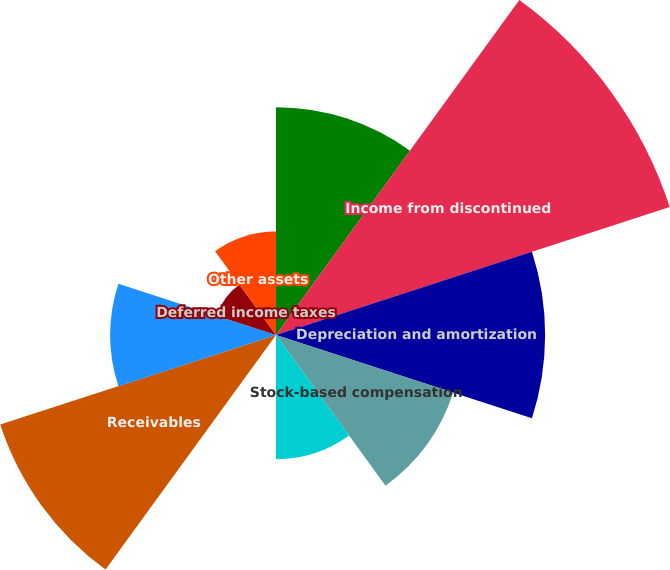Convert chart. <chart><loc_0><loc_0><loc_500><loc_500><pie_chart><fcel>Net income<fcel>Income from discontinued<fcel>Depreciation and amortization<fcel>Stock-based compensation<fcel>Net gain on sales and<fcel>Other<fcel>Receivables<fcel>Inventory prepaid expenses and<fcel>Deferred income taxes<fcel>Other assets<nl><fcel>12.36%<fcel>22.46%<fcel>14.6%<fcel>10.11%<fcel>6.74%<fcel>0.01%<fcel>15.73%<fcel>8.99%<fcel>3.38%<fcel>5.62%<nl></chart> 